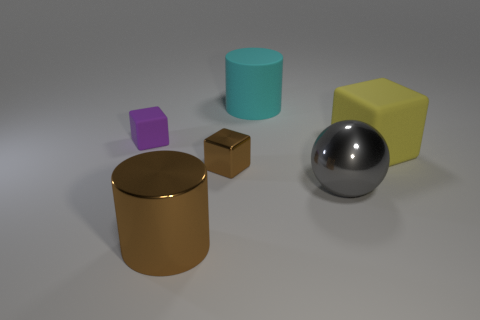There is a big cyan object; does it have the same shape as the big brown metal thing right of the tiny purple cube?
Ensure brevity in your answer.  Yes. What is the size of the shiny thing that is the same shape as the small purple rubber thing?
Keep it short and to the point. Small. Do the tiny metallic block and the big metal cylinder have the same color?
Your answer should be very brief. Yes. There is a metallic object that is on the right side of the cyan matte cylinder; is it the same size as the small rubber object?
Offer a very short reply. No. How many large things are behind the small purple object?
Make the answer very short. 1. There is a object that is in front of the yellow object and behind the large gray shiny ball; what material is it made of?
Your answer should be very brief. Metal. What number of large things are cylinders or cyan objects?
Provide a short and direct response. 2. What size is the purple rubber object?
Your answer should be compact. Small. What shape is the yellow rubber object?
Your response must be concise. Cube. Are there any other things that have the same shape as the gray shiny thing?
Your answer should be very brief. No. 